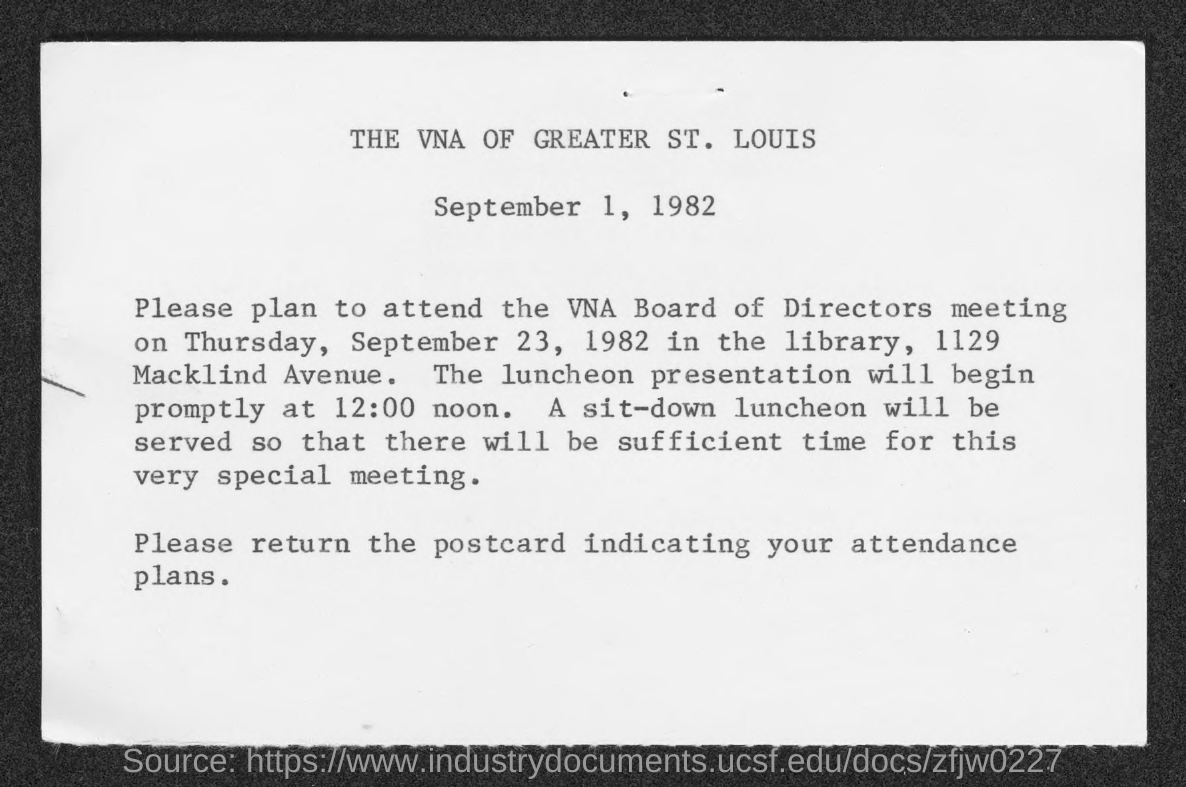Identify some key points in this picture. The date mentioned at the top of the document is September 1, 1982. 